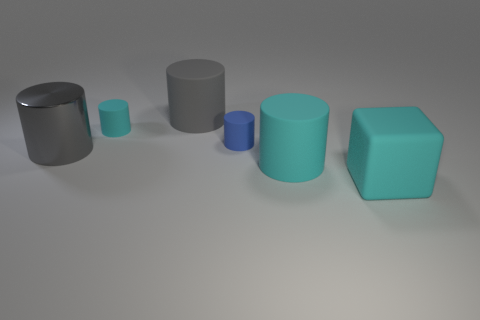Subtract all brown cubes. How many gray cylinders are left? 2 Subtract all blue cylinders. How many cylinders are left? 4 Subtract all gray cylinders. How many cylinders are left? 3 Add 1 tiny cyan cylinders. How many objects exist? 7 Subtract all cubes. How many objects are left? 5 Subtract all yellow cylinders. Subtract all purple spheres. How many cylinders are left? 5 Subtract all large brown matte cylinders. Subtract all matte blocks. How many objects are left? 5 Add 1 big gray cylinders. How many big gray cylinders are left? 3 Add 6 large brown blocks. How many large brown blocks exist? 6 Subtract 0 red balls. How many objects are left? 6 